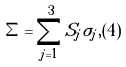<formula> <loc_0><loc_0><loc_500><loc_500>\Sigma = \sum _ { j = 1 } ^ { 3 } S _ { j } \sigma _ { j } , ( 4 )</formula> 